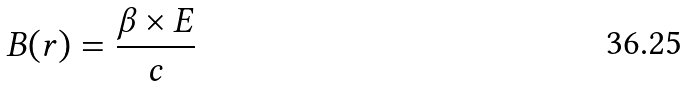Convert formula to latex. <formula><loc_0><loc_0><loc_500><loc_500>B ( r ) = \frac { \beta \times E } { c }</formula> 